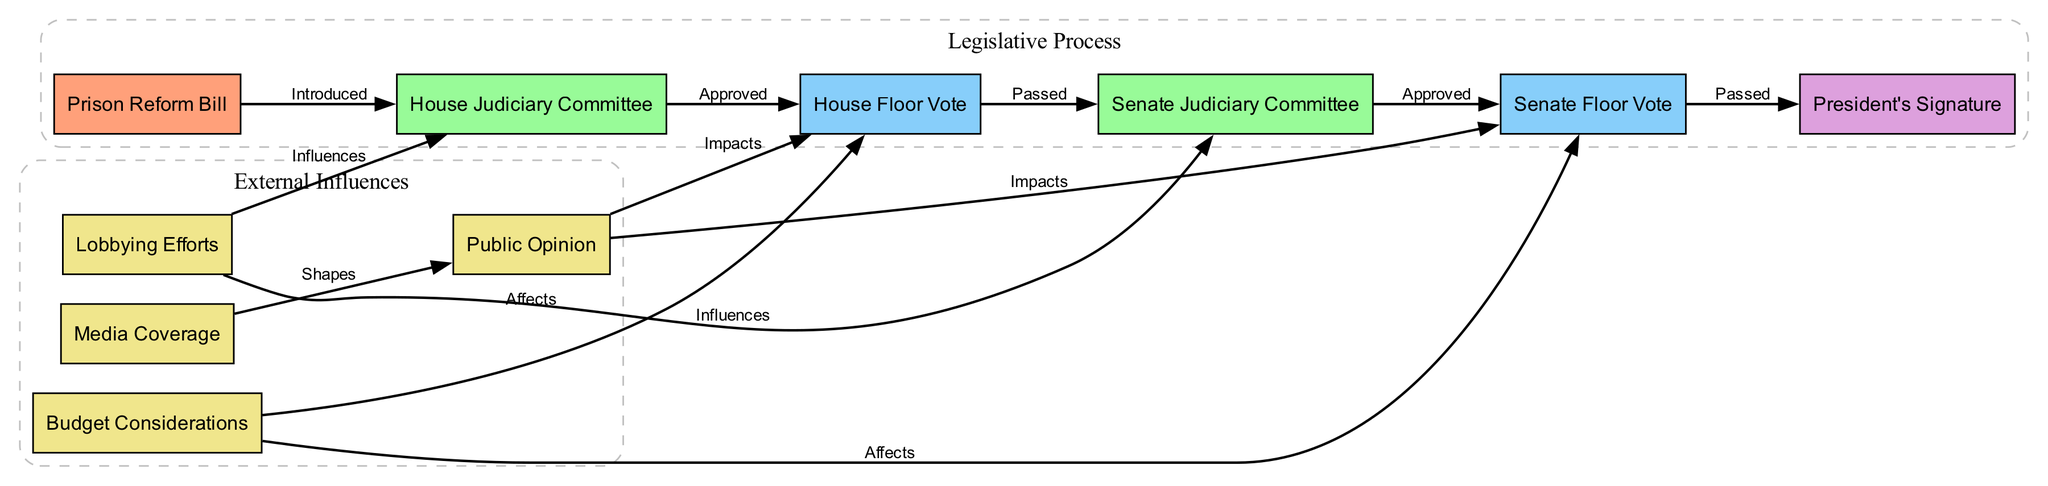What is the first step in the legislative process for a Prison Reform Bill? The diagram indicates that the Prison Reform Bill is introduced to the House Judiciary Committee, which is the first step in the process.
Answer: House Judiciary Committee How many committees are involved in the legislative process? The diagram shows two committees: the House Judiciary Committee and the Senate Judiciary Committee. Adding these together, there are a total of two committees.
Answer: 2 Which factors influence the House Floor Vote? The diagram indicates that both Lobbying Efforts and Public Opinion influence the House Floor Vote. Therefore, the factors are Lobbying Efforts and Public Opinion.
Answer: Lobbying Efforts, Public Opinion What occurs after the Prison Reform Bill is approved by the House Judiciary Committee? According to the diagram, once the House Judiciary Committee approves the bill, it moves to the House Floor Vote. This is the next step in the process.
Answer: House Floor Vote What shapes Public Opinion according to the diagram? The diagram states that Media Coverage shapes Public Opinion, providing a direct connection between the two.
Answer: Media Coverage What is the final outcome after the Senate Floor Vote? After the Senate Floor Vote, the bill is passed and then goes to the President for a signature, which is the final outcome in the process.
Answer: President's Signature How does Budget Considerations affect the Senate Floor Vote? The diagram shows a direct link indicating that Budget Considerations affect the outcome of the Senate Floor Vote, meaning that budget issues can influence whether the vote passes or not.
Answer: Affects Which step comes immediately after the Senate Judiciary Committee? The diagram indicates that after the Senate Judiciary Committee approves the bill, it moves on to the Senate Floor Vote immediately.
Answer: Senate Floor Vote What impacts both the House Floor Vote and the Senate Floor Vote? The diagram highlights that Public Opinion directly impacts both the House Floor Vote and the Senate Floor Vote, indicating its significance in the process.
Answer: Public Opinion 